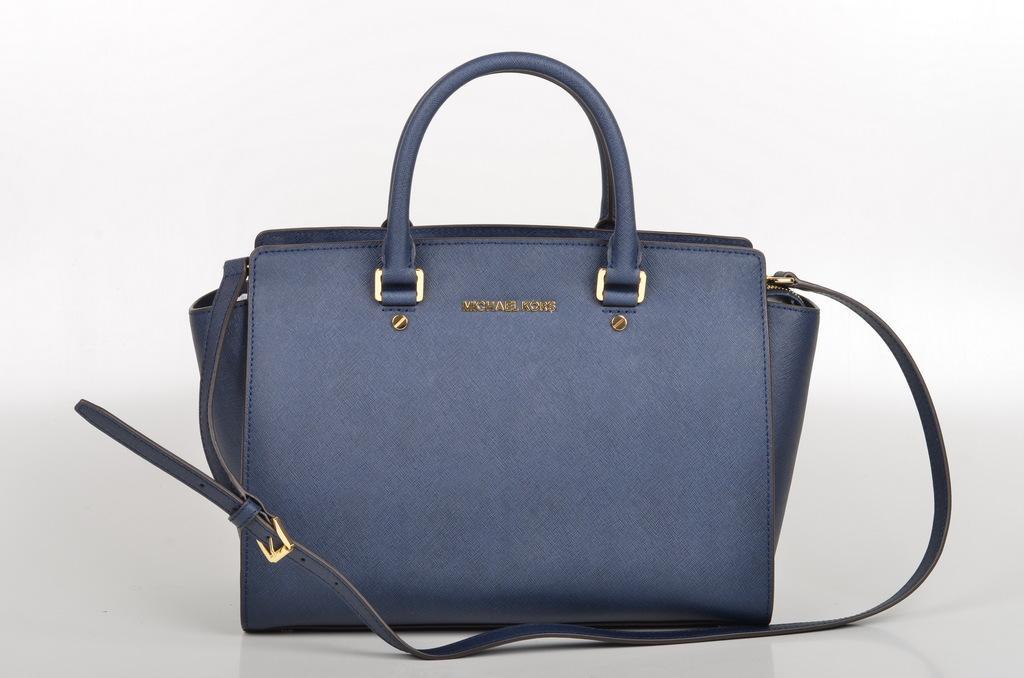How would you summarize this image in a sentence or two? In this picture we can see a bag which is in blue color. 